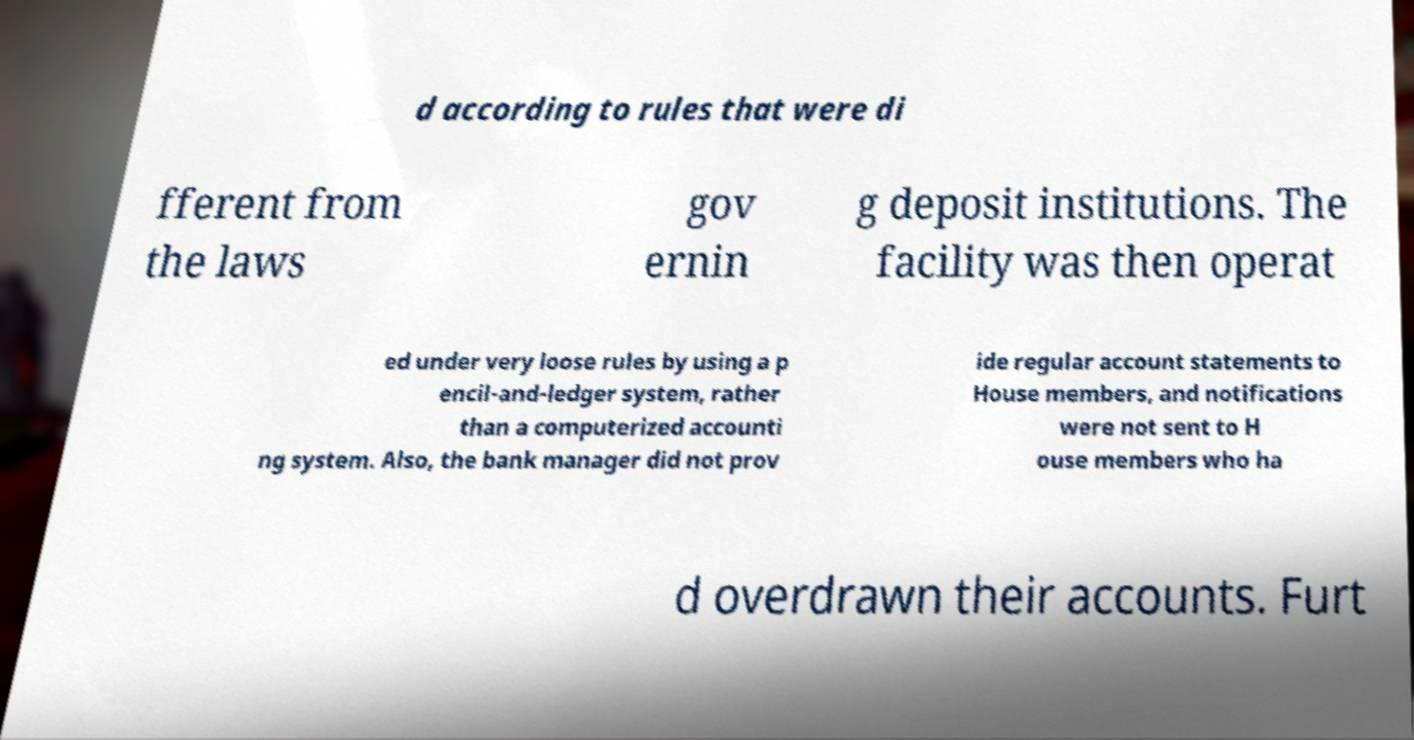Can you read and provide the text displayed in the image?This photo seems to have some interesting text. Can you extract and type it out for me? d according to rules that were di fferent from the laws gov ernin g deposit institutions. The facility was then operat ed under very loose rules by using a p encil-and-ledger system, rather than a computerized accounti ng system. Also, the bank manager did not prov ide regular account statements to House members, and notifications were not sent to H ouse members who ha d overdrawn their accounts. Furt 